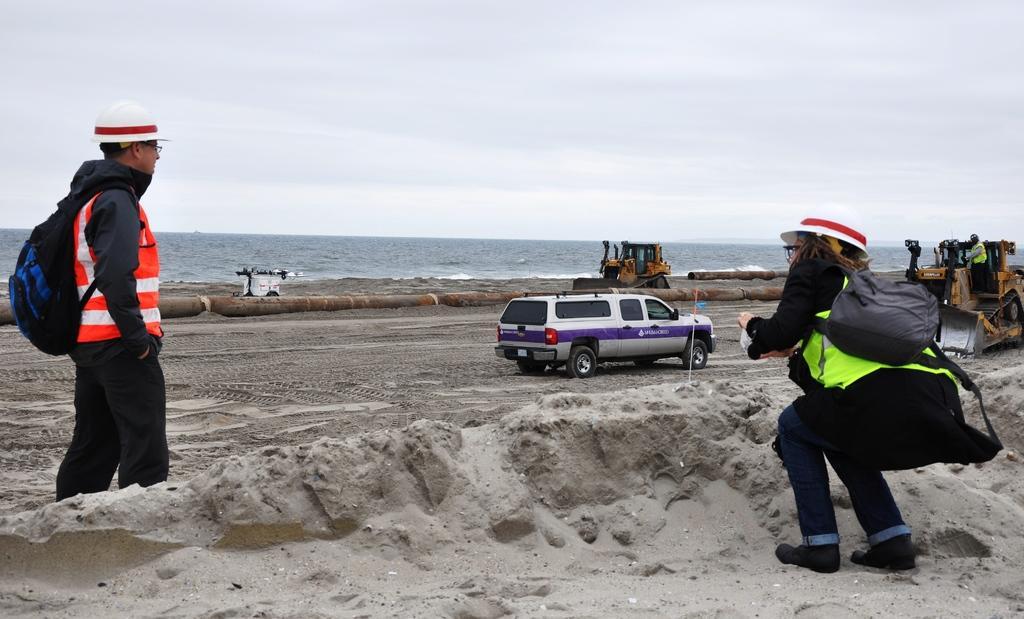In one or two sentences, can you explain what this image depicts? In this image I can see a two people wearing bags. In front I can see vehicles. They are in different color. I can see water and pipes. The sky is in white and blue color. In front I can see sand. 